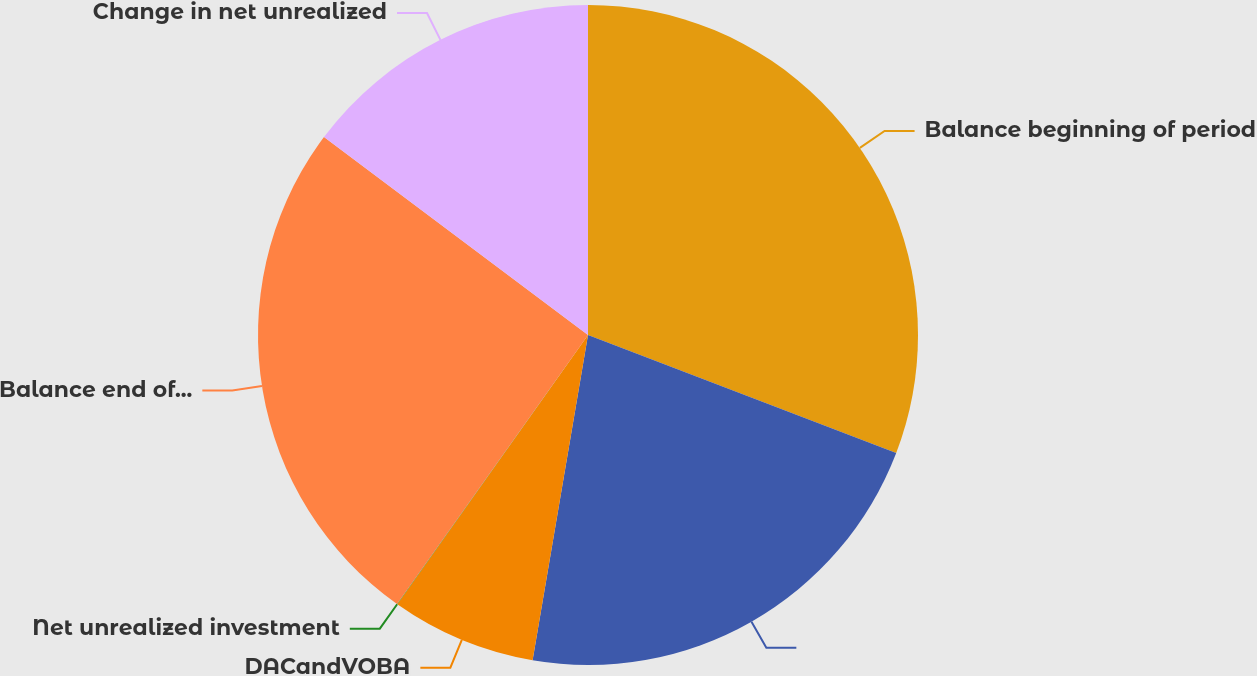<chart> <loc_0><loc_0><loc_500><loc_500><pie_chart><fcel>Balance beginning of period<fcel>Unnamed: 1<fcel>DACandVOBA<fcel>Net unrealized investment<fcel>Balance end of period<fcel>Change in net unrealized<nl><fcel>30.82%<fcel>21.87%<fcel>7.12%<fcel>0.02%<fcel>25.42%<fcel>14.76%<nl></chart> 